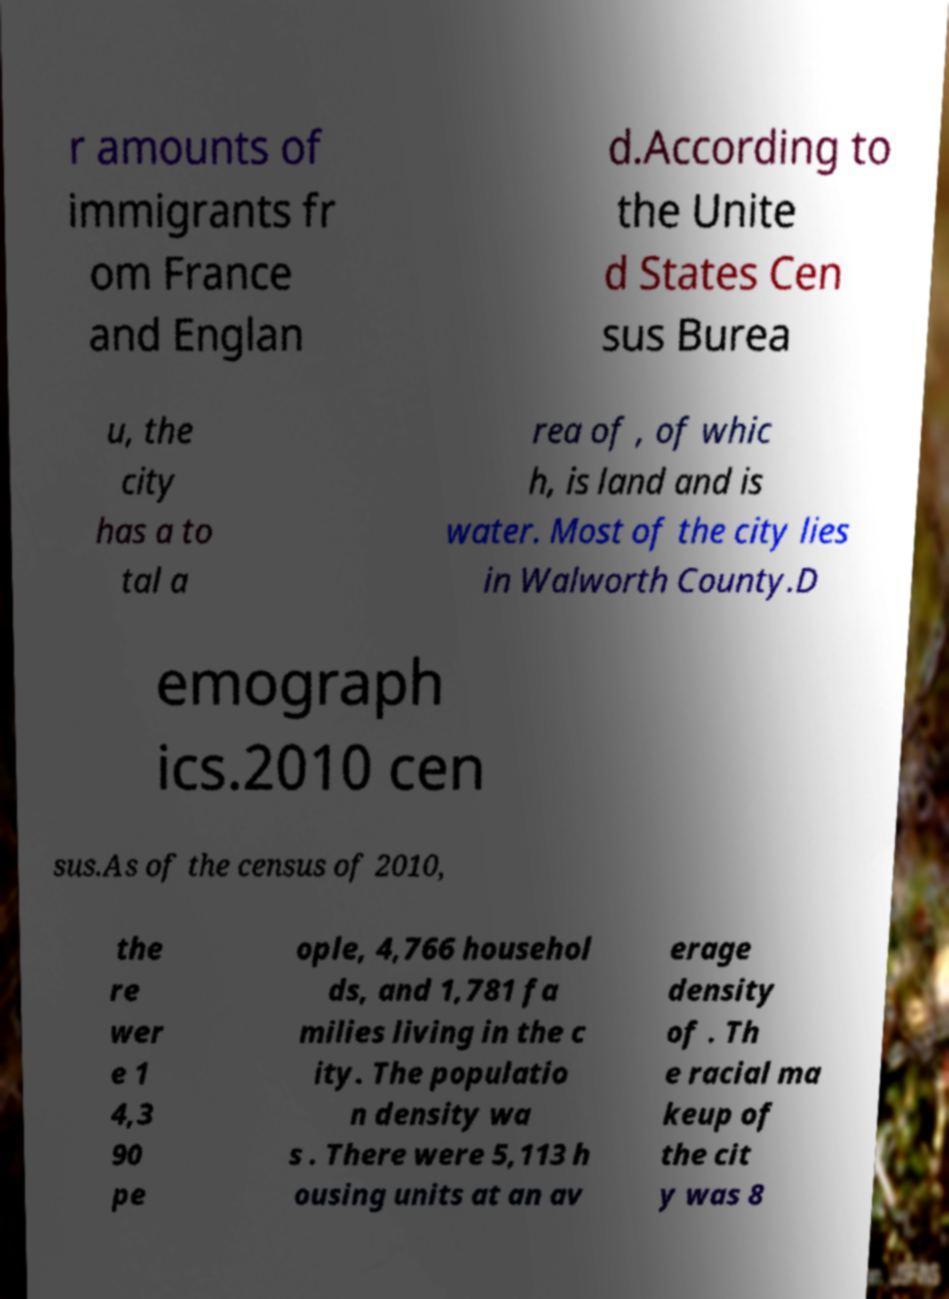There's text embedded in this image that I need extracted. Can you transcribe it verbatim? r amounts of immigrants fr om France and Englan d.According to the Unite d States Cen sus Burea u, the city has a to tal a rea of , of whic h, is land and is water. Most of the city lies in Walworth County.D emograph ics.2010 cen sus.As of the census of 2010, the re wer e 1 4,3 90 pe ople, 4,766 househol ds, and 1,781 fa milies living in the c ity. The populatio n density wa s . There were 5,113 h ousing units at an av erage density of . Th e racial ma keup of the cit y was 8 